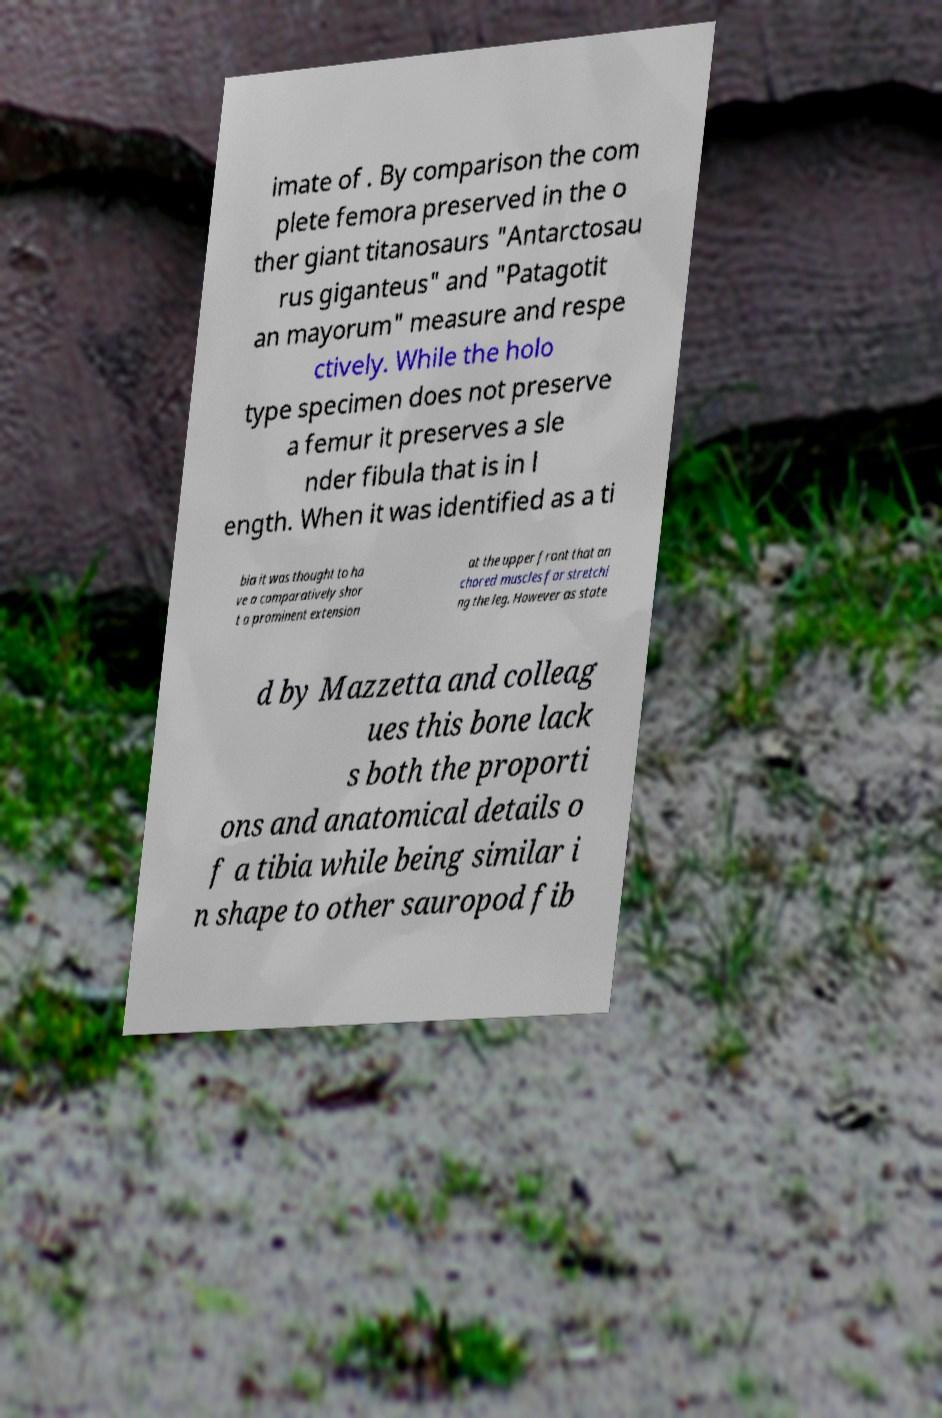What messages or text are displayed in this image? I need them in a readable, typed format. imate of . By comparison the com plete femora preserved in the o ther giant titanosaurs "Antarctosau rus giganteus" and "Patagotit an mayorum" measure and respe ctively. While the holo type specimen does not preserve a femur it preserves a sle nder fibula that is in l ength. When it was identified as a ti bia it was thought to ha ve a comparatively shor t a prominent extension at the upper front that an chored muscles for stretchi ng the leg. However as state d by Mazzetta and colleag ues this bone lack s both the proporti ons and anatomical details o f a tibia while being similar i n shape to other sauropod fib 